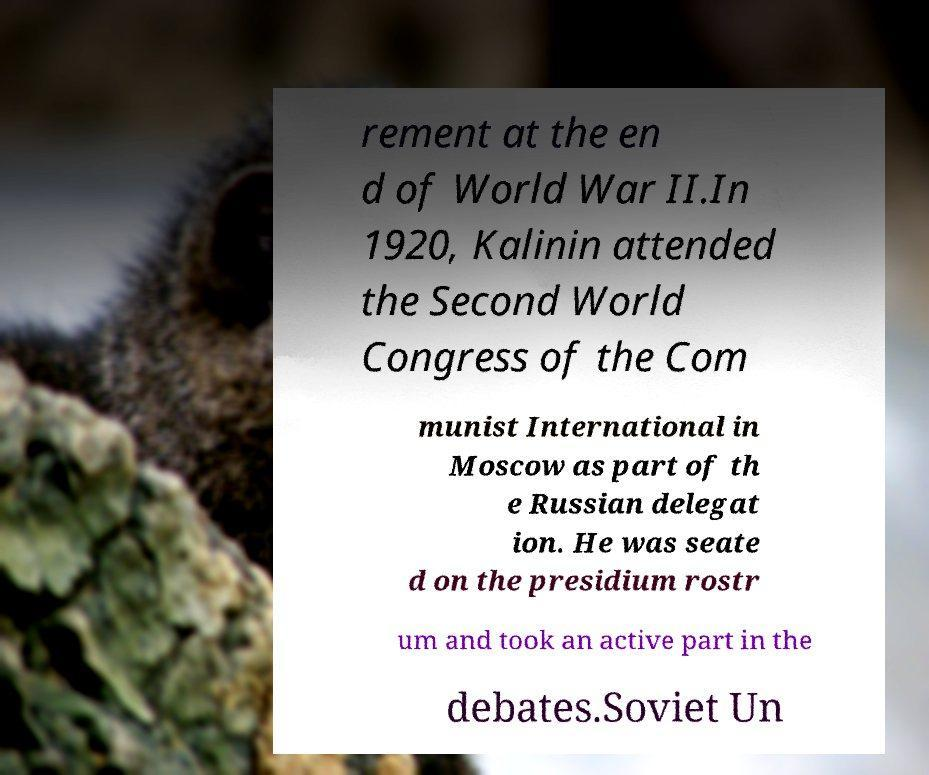Could you assist in decoding the text presented in this image and type it out clearly? rement at the en d of World War II.In 1920, Kalinin attended the Second World Congress of the Com munist International in Moscow as part of th e Russian delegat ion. He was seate d on the presidium rostr um and took an active part in the debates.Soviet Un 